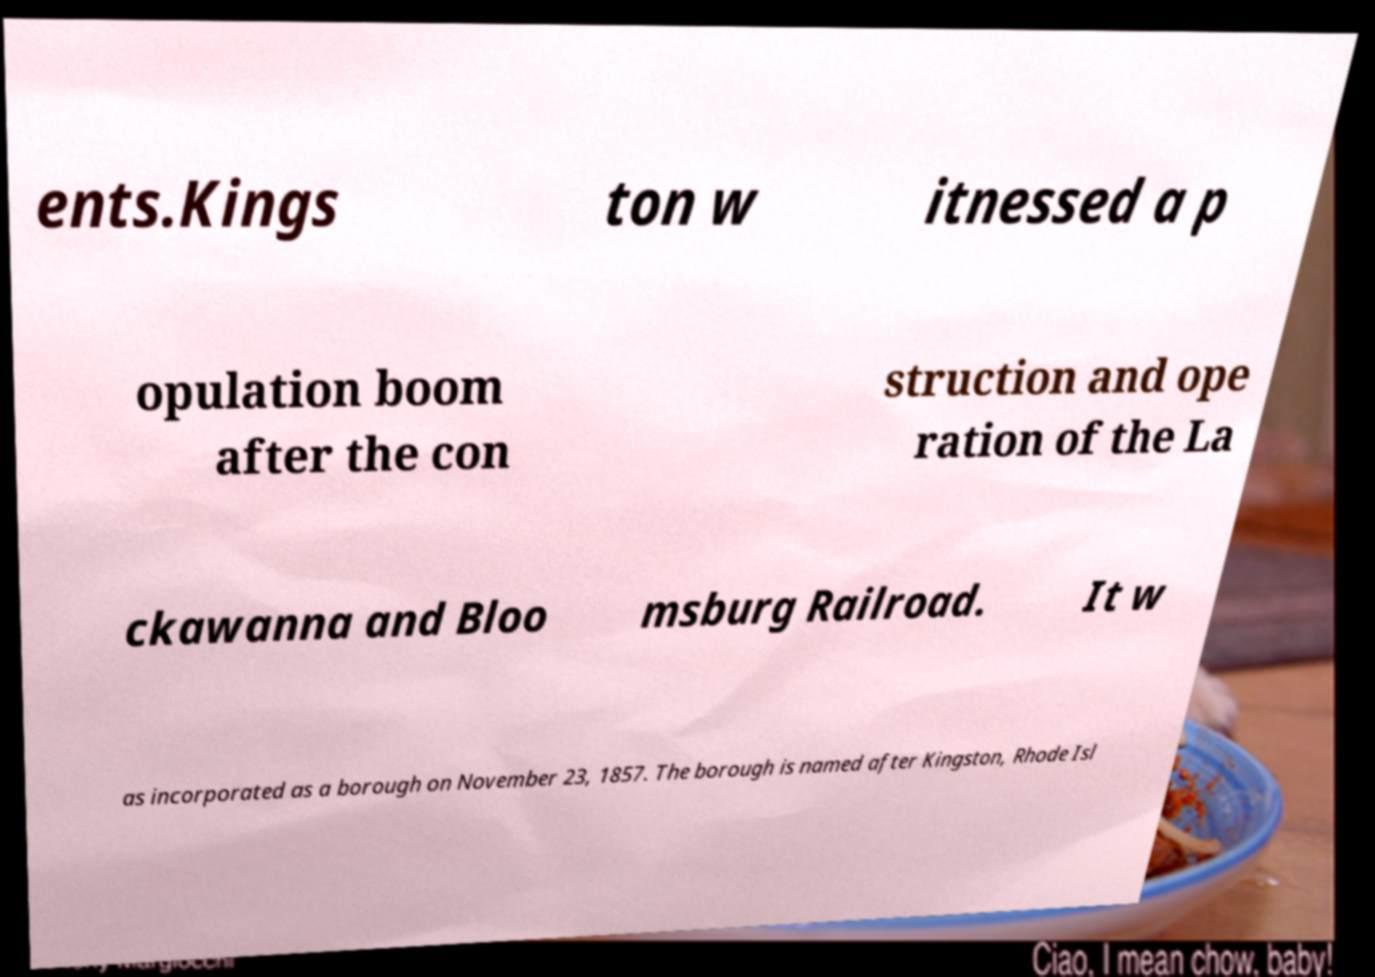Can you accurately transcribe the text from the provided image for me? ents.Kings ton w itnessed a p opulation boom after the con struction and ope ration of the La ckawanna and Bloo msburg Railroad. It w as incorporated as a borough on November 23, 1857. The borough is named after Kingston, Rhode Isl 